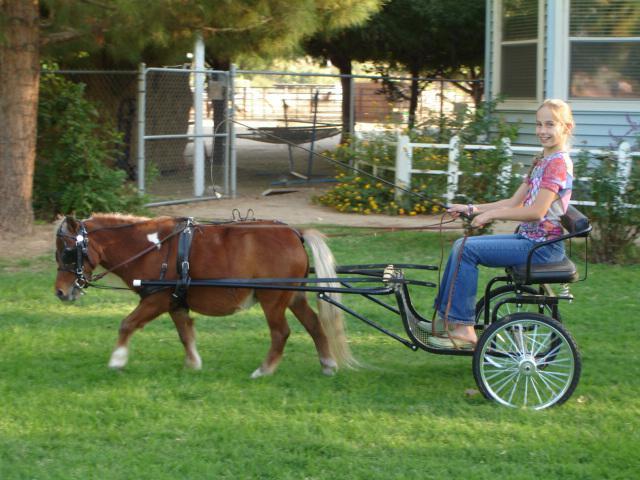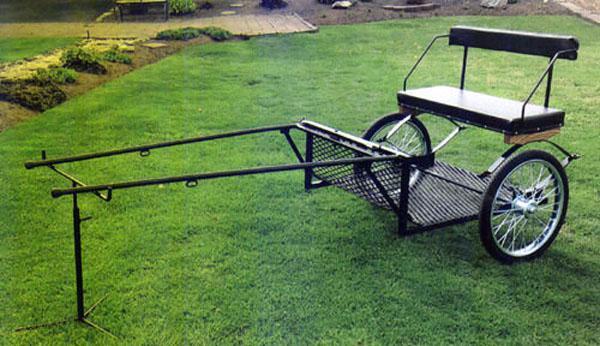The first image is the image on the left, the second image is the image on the right. Assess this claim about the two images: "There are two carts, but only one of them has a canopy.". Correct or not? Answer yes or no. No. The first image is the image on the left, the second image is the image on the right. Given the left and right images, does the statement "An image shows a four-wheeled buggy with a canopy over an upholstered seat." hold true? Answer yes or no. No. 